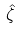<formula> <loc_0><loc_0><loc_500><loc_500>\hat { \zeta }</formula> 